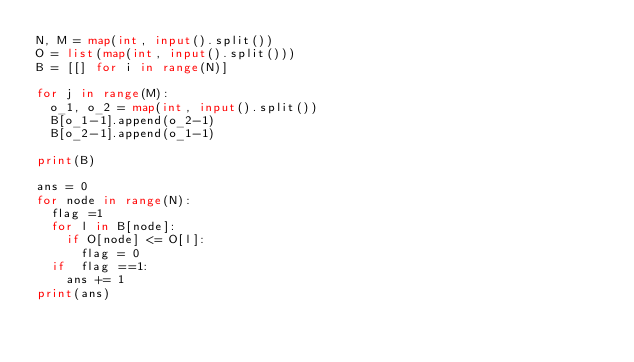Convert code to text. <code><loc_0><loc_0><loc_500><loc_500><_Python_>N, M = map(int, input().split())
O = list(map(int, input().split()))
B = [[] for i in range(N)]
 
for j in range(M):
  o_1, o_2 = map(int, input().split())
  B[o_1-1].append(o_2-1)
  B[o_2-1].append(o_1-1)
  
print(B)

ans = 0
for node in range(N):
  flag =1
  for l in B[node]:
    if O[node] <= O[l]:
      flag = 0
  if  flag ==1:
    ans += 1
print(ans)
      </code> 